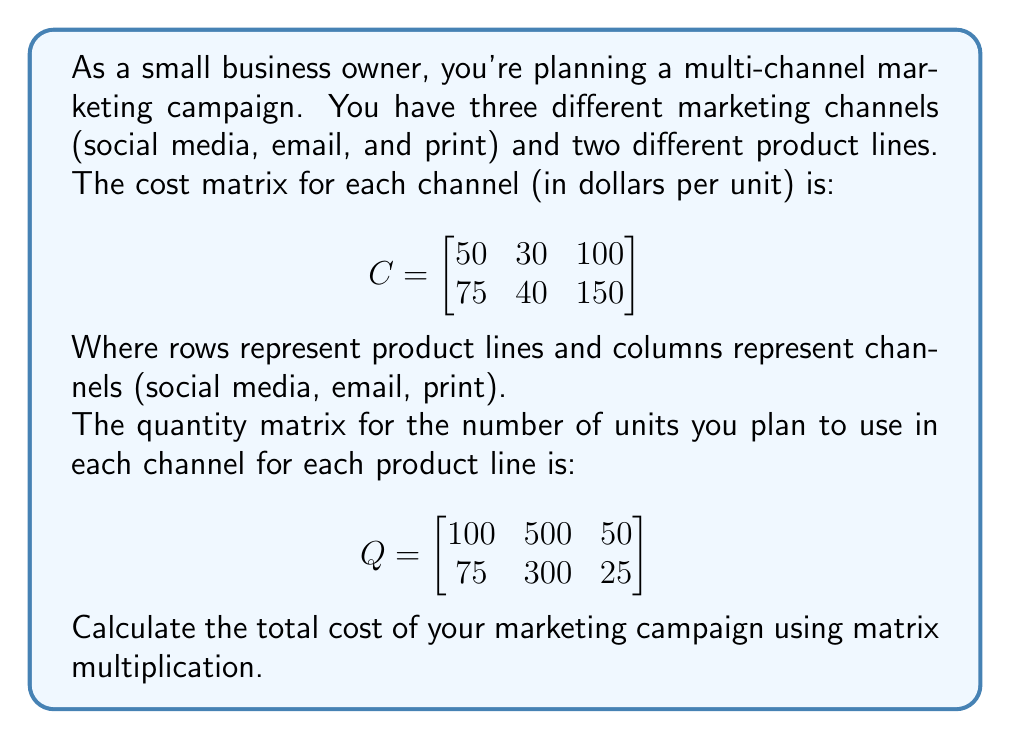Show me your answer to this math problem. To calculate the total cost of the marketing campaign, we need to perform matrix multiplication of the cost matrix (C) and the quantity matrix (Q).

Step 1: Set up the matrix multiplication
$$\text{Total Cost} = C \times Q^T$$

Where $Q^T$ is the transpose of Q.

Step 2: Transpose matrix Q
$$Q^T = \begin{bmatrix}
100 & 75 \\
500 & 300 \\
50 & 25
\end{bmatrix}$$

Step 3: Perform the matrix multiplication
$$\begin{bmatrix}
50 & 30 & 100 \\
75 & 40 & 150
\end{bmatrix} \times 
\begin{bmatrix}
100 & 75 \\
500 & 300 \\
50 & 25
\end{bmatrix}$$

Step 4: Calculate each element of the resulting matrix
$$(50 \times 100 + 30 \times 500 + 100 \times 50) = 5000 + 15000 + 5000 = 25000$$
$$(50 \times 75 + 30 \times 300 + 100 \times 25) = 3750 + 9000 + 2500 = 15250$$
$$(75 \times 100 + 40 \times 500 + 150 \times 50) = 7500 + 20000 + 7500 = 35000$$
$$(75 \times 75 + 40 \times 300 + 150 \times 25) = 5625 + 12000 + 3750 = 21375$$

Step 5: Write the resulting matrix
$$\text{Result} = \begin{bmatrix}
25000 & 15250 \\
35000 & 21375
\end{bmatrix}$$

Step 6: Sum all elements in the resulting matrix to get the total cost
Total Cost = 25000 + 15250 + 35000 + 21375 = 96625
Answer: $96625 